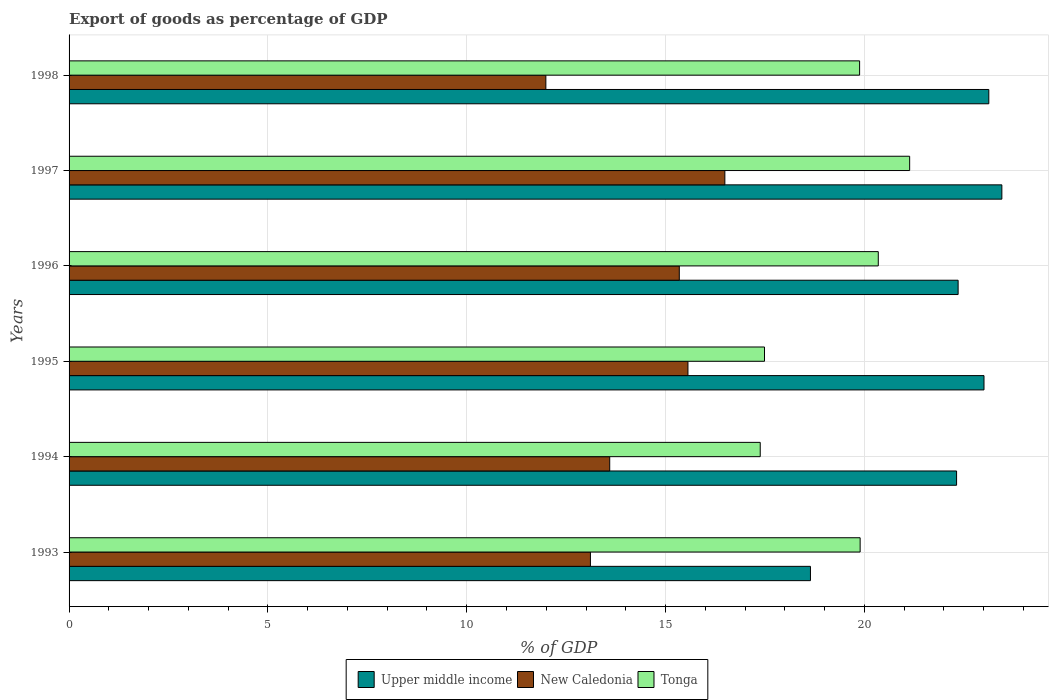How many different coloured bars are there?
Your answer should be compact. 3. How many groups of bars are there?
Your answer should be very brief. 6. Are the number of bars per tick equal to the number of legend labels?
Your response must be concise. Yes. How many bars are there on the 5th tick from the top?
Ensure brevity in your answer.  3. How many bars are there on the 5th tick from the bottom?
Make the answer very short. 3. What is the export of goods as percentage of GDP in New Caledonia in 1995?
Keep it short and to the point. 15.56. Across all years, what is the maximum export of goods as percentage of GDP in Upper middle income?
Your answer should be compact. 23.46. Across all years, what is the minimum export of goods as percentage of GDP in Upper middle income?
Ensure brevity in your answer.  18.64. What is the total export of goods as percentage of GDP in Tonga in the graph?
Offer a terse response. 116.13. What is the difference between the export of goods as percentage of GDP in New Caledonia in 1994 and that in 1997?
Ensure brevity in your answer.  -2.9. What is the difference between the export of goods as percentage of GDP in Tonga in 1993 and the export of goods as percentage of GDP in Upper middle income in 1996?
Offer a terse response. -2.46. What is the average export of goods as percentage of GDP in Tonga per year?
Make the answer very short. 19.36. In the year 1996, what is the difference between the export of goods as percentage of GDP in Tonga and export of goods as percentage of GDP in Upper middle income?
Keep it short and to the point. -2.01. What is the ratio of the export of goods as percentage of GDP in New Caledonia in 1996 to that in 1997?
Your response must be concise. 0.93. Is the export of goods as percentage of GDP in Tonga in 1993 less than that in 1996?
Ensure brevity in your answer.  Yes. What is the difference between the highest and the second highest export of goods as percentage of GDP in Tonga?
Provide a short and direct response. 0.79. What is the difference between the highest and the lowest export of goods as percentage of GDP in New Caledonia?
Your response must be concise. 4.5. In how many years, is the export of goods as percentage of GDP in New Caledonia greater than the average export of goods as percentage of GDP in New Caledonia taken over all years?
Provide a short and direct response. 3. What does the 3rd bar from the top in 1996 represents?
Ensure brevity in your answer.  Upper middle income. What does the 2nd bar from the bottom in 1993 represents?
Your answer should be compact. New Caledonia. How many bars are there?
Provide a short and direct response. 18. Are all the bars in the graph horizontal?
Provide a short and direct response. Yes. How many years are there in the graph?
Provide a succinct answer. 6. Does the graph contain any zero values?
Make the answer very short. No. Where does the legend appear in the graph?
Your response must be concise. Bottom center. How are the legend labels stacked?
Offer a very short reply. Horizontal. What is the title of the graph?
Offer a terse response. Export of goods as percentage of GDP. What is the label or title of the X-axis?
Your answer should be compact. % of GDP. What is the % of GDP of Upper middle income in 1993?
Your answer should be very brief. 18.64. What is the % of GDP of New Caledonia in 1993?
Your answer should be compact. 13.11. What is the % of GDP in Tonga in 1993?
Your answer should be very brief. 19.89. What is the % of GDP in Upper middle income in 1994?
Your answer should be very brief. 22.32. What is the % of GDP of New Caledonia in 1994?
Offer a terse response. 13.6. What is the % of GDP in Tonga in 1994?
Your answer should be compact. 17.38. What is the % of GDP in Upper middle income in 1995?
Make the answer very short. 23.01. What is the % of GDP of New Caledonia in 1995?
Your answer should be compact. 15.56. What is the % of GDP of Tonga in 1995?
Provide a succinct answer. 17.49. What is the % of GDP of Upper middle income in 1996?
Make the answer very short. 22.36. What is the % of GDP in New Caledonia in 1996?
Make the answer very short. 15.35. What is the % of GDP in Tonga in 1996?
Your answer should be very brief. 20.35. What is the % of GDP of Upper middle income in 1997?
Your response must be concise. 23.46. What is the % of GDP of New Caledonia in 1997?
Your answer should be compact. 16.49. What is the % of GDP in Tonga in 1997?
Offer a very short reply. 21.14. What is the % of GDP in Upper middle income in 1998?
Make the answer very short. 23.13. What is the % of GDP of New Caledonia in 1998?
Keep it short and to the point. 11.99. What is the % of GDP of Tonga in 1998?
Make the answer very short. 19.88. Across all years, what is the maximum % of GDP of Upper middle income?
Offer a very short reply. 23.46. Across all years, what is the maximum % of GDP of New Caledonia?
Your answer should be very brief. 16.49. Across all years, what is the maximum % of GDP of Tonga?
Make the answer very short. 21.14. Across all years, what is the minimum % of GDP in Upper middle income?
Ensure brevity in your answer.  18.64. Across all years, what is the minimum % of GDP in New Caledonia?
Your answer should be very brief. 11.99. Across all years, what is the minimum % of GDP in Tonga?
Keep it short and to the point. 17.38. What is the total % of GDP of Upper middle income in the graph?
Offer a very short reply. 132.92. What is the total % of GDP of New Caledonia in the graph?
Keep it short and to the point. 86.1. What is the total % of GDP in Tonga in the graph?
Ensure brevity in your answer.  116.13. What is the difference between the % of GDP in Upper middle income in 1993 and that in 1994?
Your answer should be compact. -3.67. What is the difference between the % of GDP in New Caledonia in 1993 and that in 1994?
Your answer should be compact. -0.48. What is the difference between the % of GDP of Tonga in 1993 and that in 1994?
Make the answer very short. 2.51. What is the difference between the % of GDP in Upper middle income in 1993 and that in 1995?
Provide a succinct answer. -4.36. What is the difference between the % of GDP of New Caledonia in 1993 and that in 1995?
Your answer should be very brief. -2.45. What is the difference between the % of GDP in Tonga in 1993 and that in 1995?
Ensure brevity in your answer.  2.41. What is the difference between the % of GDP in Upper middle income in 1993 and that in 1996?
Your answer should be compact. -3.71. What is the difference between the % of GDP of New Caledonia in 1993 and that in 1996?
Ensure brevity in your answer.  -2.24. What is the difference between the % of GDP of Tonga in 1993 and that in 1996?
Give a very brief answer. -0.46. What is the difference between the % of GDP in Upper middle income in 1993 and that in 1997?
Offer a very short reply. -4.81. What is the difference between the % of GDP in New Caledonia in 1993 and that in 1997?
Your answer should be very brief. -3.38. What is the difference between the % of GDP in Tonga in 1993 and that in 1997?
Your answer should be very brief. -1.25. What is the difference between the % of GDP in Upper middle income in 1993 and that in 1998?
Your response must be concise. -4.49. What is the difference between the % of GDP in New Caledonia in 1993 and that in 1998?
Give a very brief answer. 1.12. What is the difference between the % of GDP of Tonga in 1993 and that in 1998?
Offer a terse response. 0.01. What is the difference between the % of GDP in Upper middle income in 1994 and that in 1995?
Ensure brevity in your answer.  -0.69. What is the difference between the % of GDP in New Caledonia in 1994 and that in 1995?
Provide a succinct answer. -1.97. What is the difference between the % of GDP of Tonga in 1994 and that in 1995?
Your answer should be compact. -0.11. What is the difference between the % of GDP in Upper middle income in 1994 and that in 1996?
Ensure brevity in your answer.  -0.04. What is the difference between the % of GDP in New Caledonia in 1994 and that in 1996?
Make the answer very short. -1.75. What is the difference between the % of GDP in Tonga in 1994 and that in 1996?
Your answer should be compact. -2.97. What is the difference between the % of GDP of Upper middle income in 1994 and that in 1997?
Make the answer very short. -1.14. What is the difference between the % of GDP of New Caledonia in 1994 and that in 1997?
Provide a succinct answer. -2.9. What is the difference between the % of GDP of Tonga in 1994 and that in 1997?
Make the answer very short. -3.76. What is the difference between the % of GDP of Upper middle income in 1994 and that in 1998?
Offer a very short reply. -0.81. What is the difference between the % of GDP of New Caledonia in 1994 and that in 1998?
Give a very brief answer. 1.61. What is the difference between the % of GDP of Tonga in 1994 and that in 1998?
Your response must be concise. -2.5. What is the difference between the % of GDP in Upper middle income in 1995 and that in 1996?
Your response must be concise. 0.65. What is the difference between the % of GDP of New Caledonia in 1995 and that in 1996?
Your response must be concise. 0.22. What is the difference between the % of GDP in Tonga in 1995 and that in 1996?
Offer a terse response. -2.86. What is the difference between the % of GDP in Upper middle income in 1995 and that in 1997?
Offer a terse response. -0.45. What is the difference between the % of GDP of New Caledonia in 1995 and that in 1997?
Make the answer very short. -0.93. What is the difference between the % of GDP in Tonga in 1995 and that in 1997?
Offer a very short reply. -3.65. What is the difference between the % of GDP in Upper middle income in 1995 and that in 1998?
Your response must be concise. -0.12. What is the difference between the % of GDP of New Caledonia in 1995 and that in 1998?
Keep it short and to the point. 3.57. What is the difference between the % of GDP in Tonga in 1995 and that in 1998?
Provide a short and direct response. -2.39. What is the difference between the % of GDP in Upper middle income in 1996 and that in 1997?
Your answer should be compact. -1.1. What is the difference between the % of GDP in New Caledonia in 1996 and that in 1997?
Offer a terse response. -1.15. What is the difference between the % of GDP of Tonga in 1996 and that in 1997?
Your answer should be compact. -0.79. What is the difference between the % of GDP in Upper middle income in 1996 and that in 1998?
Your answer should be very brief. -0.77. What is the difference between the % of GDP of New Caledonia in 1996 and that in 1998?
Your answer should be very brief. 3.36. What is the difference between the % of GDP in Tonga in 1996 and that in 1998?
Give a very brief answer. 0.47. What is the difference between the % of GDP of Upper middle income in 1997 and that in 1998?
Ensure brevity in your answer.  0.33. What is the difference between the % of GDP in New Caledonia in 1997 and that in 1998?
Your answer should be very brief. 4.5. What is the difference between the % of GDP in Tonga in 1997 and that in 1998?
Provide a succinct answer. 1.26. What is the difference between the % of GDP in Upper middle income in 1993 and the % of GDP in New Caledonia in 1994?
Provide a succinct answer. 5.05. What is the difference between the % of GDP of Upper middle income in 1993 and the % of GDP of Tonga in 1994?
Provide a short and direct response. 1.26. What is the difference between the % of GDP in New Caledonia in 1993 and the % of GDP in Tonga in 1994?
Your answer should be compact. -4.27. What is the difference between the % of GDP of Upper middle income in 1993 and the % of GDP of New Caledonia in 1995?
Offer a very short reply. 3.08. What is the difference between the % of GDP in Upper middle income in 1993 and the % of GDP in Tonga in 1995?
Provide a succinct answer. 1.16. What is the difference between the % of GDP in New Caledonia in 1993 and the % of GDP in Tonga in 1995?
Your answer should be very brief. -4.38. What is the difference between the % of GDP of Upper middle income in 1993 and the % of GDP of New Caledonia in 1996?
Ensure brevity in your answer.  3.3. What is the difference between the % of GDP of Upper middle income in 1993 and the % of GDP of Tonga in 1996?
Make the answer very short. -1.71. What is the difference between the % of GDP of New Caledonia in 1993 and the % of GDP of Tonga in 1996?
Provide a short and direct response. -7.24. What is the difference between the % of GDP in Upper middle income in 1993 and the % of GDP in New Caledonia in 1997?
Provide a succinct answer. 2.15. What is the difference between the % of GDP of Upper middle income in 1993 and the % of GDP of Tonga in 1997?
Keep it short and to the point. -2.49. What is the difference between the % of GDP in New Caledonia in 1993 and the % of GDP in Tonga in 1997?
Provide a succinct answer. -8.03. What is the difference between the % of GDP in Upper middle income in 1993 and the % of GDP in New Caledonia in 1998?
Your response must be concise. 6.65. What is the difference between the % of GDP of Upper middle income in 1993 and the % of GDP of Tonga in 1998?
Give a very brief answer. -1.24. What is the difference between the % of GDP of New Caledonia in 1993 and the % of GDP of Tonga in 1998?
Give a very brief answer. -6.77. What is the difference between the % of GDP in Upper middle income in 1994 and the % of GDP in New Caledonia in 1995?
Give a very brief answer. 6.76. What is the difference between the % of GDP in Upper middle income in 1994 and the % of GDP in Tonga in 1995?
Offer a terse response. 4.83. What is the difference between the % of GDP of New Caledonia in 1994 and the % of GDP of Tonga in 1995?
Provide a succinct answer. -3.89. What is the difference between the % of GDP in Upper middle income in 1994 and the % of GDP in New Caledonia in 1996?
Offer a very short reply. 6.97. What is the difference between the % of GDP in Upper middle income in 1994 and the % of GDP in Tonga in 1996?
Your answer should be very brief. 1.97. What is the difference between the % of GDP of New Caledonia in 1994 and the % of GDP of Tonga in 1996?
Provide a succinct answer. -6.75. What is the difference between the % of GDP in Upper middle income in 1994 and the % of GDP in New Caledonia in 1997?
Keep it short and to the point. 5.83. What is the difference between the % of GDP in Upper middle income in 1994 and the % of GDP in Tonga in 1997?
Give a very brief answer. 1.18. What is the difference between the % of GDP in New Caledonia in 1994 and the % of GDP in Tonga in 1997?
Provide a succinct answer. -7.54. What is the difference between the % of GDP of Upper middle income in 1994 and the % of GDP of New Caledonia in 1998?
Your answer should be compact. 10.33. What is the difference between the % of GDP of Upper middle income in 1994 and the % of GDP of Tonga in 1998?
Keep it short and to the point. 2.44. What is the difference between the % of GDP of New Caledonia in 1994 and the % of GDP of Tonga in 1998?
Your answer should be compact. -6.28. What is the difference between the % of GDP in Upper middle income in 1995 and the % of GDP in New Caledonia in 1996?
Your response must be concise. 7.66. What is the difference between the % of GDP of Upper middle income in 1995 and the % of GDP of Tonga in 1996?
Your answer should be very brief. 2.66. What is the difference between the % of GDP in New Caledonia in 1995 and the % of GDP in Tonga in 1996?
Make the answer very short. -4.79. What is the difference between the % of GDP in Upper middle income in 1995 and the % of GDP in New Caledonia in 1997?
Keep it short and to the point. 6.52. What is the difference between the % of GDP in Upper middle income in 1995 and the % of GDP in Tonga in 1997?
Provide a succinct answer. 1.87. What is the difference between the % of GDP in New Caledonia in 1995 and the % of GDP in Tonga in 1997?
Provide a short and direct response. -5.58. What is the difference between the % of GDP of Upper middle income in 1995 and the % of GDP of New Caledonia in 1998?
Give a very brief answer. 11.02. What is the difference between the % of GDP in Upper middle income in 1995 and the % of GDP in Tonga in 1998?
Provide a succinct answer. 3.13. What is the difference between the % of GDP in New Caledonia in 1995 and the % of GDP in Tonga in 1998?
Your answer should be very brief. -4.32. What is the difference between the % of GDP in Upper middle income in 1996 and the % of GDP in New Caledonia in 1997?
Your answer should be very brief. 5.87. What is the difference between the % of GDP in Upper middle income in 1996 and the % of GDP in Tonga in 1997?
Your answer should be very brief. 1.22. What is the difference between the % of GDP of New Caledonia in 1996 and the % of GDP of Tonga in 1997?
Your response must be concise. -5.79. What is the difference between the % of GDP of Upper middle income in 1996 and the % of GDP of New Caledonia in 1998?
Provide a short and direct response. 10.37. What is the difference between the % of GDP in Upper middle income in 1996 and the % of GDP in Tonga in 1998?
Keep it short and to the point. 2.48. What is the difference between the % of GDP of New Caledonia in 1996 and the % of GDP of Tonga in 1998?
Ensure brevity in your answer.  -4.53. What is the difference between the % of GDP in Upper middle income in 1997 and the % of GDP in New Caledonia in 1998?
Offer a very short reply. 11.47. What is the difference between the % of GDP of Upper middle income in 1997 and the % of GDP of Tonga in 1998?
Your answer should be compact. 3.58. What is the difference between the % of GDP in New Caledonia in 1997 and the % of GDP in Tonga in 1998?
Give a very brief answer. -3.39. What is the average % of GDP of Upper middle income per year?
Provide a succinct answer. 22.15. What is the average % of GDP of New Caledonia per year?
Offer a terse response. 14.35. What is the average % of GDP in Tonga per year?
Offer a terse response. 19.36. In the year 1993, what is the difference between the % of GDP of Upper middle income and % of GDP of New Caledonia?
Ensure brevity in your answer.  5.53. In the year 1993, what is the difference between the % of GDP of Upper middle income and % of GDP of Tonga?
Provide a short and direct response. -1.25. In the year 1993, what is the difference between the % of GDP in New Caledonia and % of GDP in Tonga?
Offer a terse response. -6.78. In the year 1994, what is the difference between the % of GDP in Upper middle income and % of GDP in New Caledonia?
Provide a succinct answer. 8.72. In the year 1994, what is the difference between the % of GDP of Upper middle income and % of GDP of Tonga?
Offer a very short reply. 4.94. In the year 1994, what is the difference between the % of GDP of New Caledonia and % of GDP of Tonga?
Your response must be concise. -3.79. In the year 1995, what is the difference between the % of GDP in Upper middle income and % of GDP in New Caledonia?
Your answer should be compact. 7.45. In the year 1995, what is the difference between the % of GDP of Upper middle income and % of GDP of Tonga?
Keep it short and to the point. 5.52. In the year 1995, what is the difference between the % of GDP of New Caledonia and % of GDP of Tonga?
Offer a very short reply. -1.92. In the year 1996, what is the difference between the % of GDP of Upper middle income and % of GDP of New Caledonia?
Your answer should be very brief. 7.01. In the year 1996, what is the difference between the % of GDP in Upper middle income and % of GDP in Tonga?
Provide a succinct answer. 2.01. In the year 1996, what is the difference between the % of GDP in New Caledonia and % of GDP in Tonga?
Your answer should be compact. -5. In the year 1997, what is the difference between the % of GDP in Upper middle income and % of GDP in New Caledonia?
Give a very brief answer. 6.97. In the year 1997, what is the difference between the % of GDP of Upper middle income and % of GDP of Tonga?
Give a very brief answer. 2.32. In the year 1997, what is the difference between the % of GDP in New Caledonia and % of GDP in Tonga?
Give a very brief answer. -4.65. In the year 1998, what is the difference between the % of GDP in Upper middle income and % of GDP in New Caledonia?
Give a very brief answer. 11.14. In the year 1998, what is the difference between the % of GDP in Upper middle income and % of GDP in Tonga?
Offer a very short reply. 3.25. In the year 1998, what is the difference between the % of GDP in New Caledonia and % of GDP in Tonga?
Your answer should be very brief. -7.89. What is the ratio of the % of GDP in Upper middle income in 1993 to that in 1994?
Your answer should be very brief. 0.84. What is the ratio of the % of GDP in New Caledonia in 1993 to that in 1994?
Your response must be concise. 0.96. What is the ratio of the % of GDP of Tonga in 1993 to that in 1994?
Your answer should be very brief. 1.14. What is the ratio of the % of GDP of Upper middle income in 1993 to that in 1995?
Your answer should be very brief. 0.81. What is the ratio of the % of GDP in New Caledonia in 1993 to that in 1995?
Provide a short and direct response. 0.84. What is the ratio of the % of GDP in Tonga in 1993 to that in 1995?
Ensure brevity in your answer.  1.14. What is the ratio of the % of GDP in Upper middle income in 1993 to that in 1996?
Provide a short and direct response. 0.83. What is the ratio of the % of GDP of New Caledonia in 1993 to that in 1996?
Ensure brevity in your answer.  0.85. What is the ratio of the % of GDP in Tonga in 1993 to that in 1996?
Provide a succinct answer. 0.98. What is the ratio of the % of GDP of Upper middle income in 1993 to that in 1997?
Your answer should be compact. 0.79. What is the ratio of the % of GDP of New Caledonia in 1993 to that in 1997?
Make the answer very short. 0.8. What is the ratio of the % of GDP in Tonga in 1993 to that in 1997?
Provide a short and direct response. 0.94. What is the ratio of the % of GDP in Upper middle income in 1993 to that in 1998?
Provide a short and direct response. 0.81. What is the ratio of the % of GDP in New Caledonia in 1993 to that in 1998?
Your answer should be very brief. 1.09. What is the ratio of the % of GDP of Upper middle income in 1994 to that in 1995?
Your response must be concise. 0.97. What is the ratio of the % of GDP in New Caledonia in 1994 to that in 1995?
Your answer should be compact. 0.87. What is the ratio of the % of GDP in Upper middle income in 1994 to that in 1996?
Provide a short and direct response. 1. What is the ratio of the % of GDP in New Caledonia in 1994 to that in 1996?
Ensure brevity in your answer.  0.89. What is the ratio of the % of GDP in Tonga in 1994 to that in 1996?
Keep it short and to the point. 0.85. What is the ratio of the % of GDP of Upper middle income in 1994 to that in 1997?
Your answer should be compact. 0.95. What is the ratio of the % of GDP of New Caledonia in 1994 to that in 1997?
Your answer should be compact. 0.82. What is the ratio of the % of GDP of Tonga in 1994 to that in 1997?
Keep it short and to the point. 0.82. What is the ratio of the % of GDP in Upper middle income in 1994 to that in 1998?
Your answer should be compact. 0.96. What is the ratio of the % of GDP of New Caledonia in 1994 to that in 1998?
Your response must be concise. 1.13. What is the ratio of the % of GDP of Tonga in 1994 to that in 1998?
Make the answer very short. 0.87. What is the ratio of the % of GDP of Upper middle income in 1995 to that in 1996?
Your answer should be compact. 1.03. What is the ratio of the % of GDP in New Caledonia in 1995 to that in 1996?
Give a very brief answer. 1.01. What is the ratio of the % of GDP in Tonga in 1995 to that in 1996?
Give a very brief answer. 0.86. What is the ratio of the % of GDP of Upper middle income in 1995 to that in 1997?
Keep it short and to the point. 0.98. What is the ratio of the % of GDP in New Caledonia in 1995 to that in 1997?
Your answer should be compact. 0.94. What is the ratio of the % of GDP in Tonga in 1995 to that in 1997?
Your answer should be compact. 0.83. What is the ratio of the % of GDP of New Caledonia in 1995 to that in 1998?
Your answer should be compact. 1.3. What is the ratio of the % of GDP in Tonga in 1995 to that in 1998?
Your answer should be very brief. 0.88. What is the ratio of the % of GDP of Upper middle income in 1996 to that in 1997?
Provide a short and direct response. 0.95. What is the ratio of the % of GDP in New Caledonia in 1996 to that in 1997?
Offer a terse response. 0.93. What is the ratio of the % of GDP of Tonga in 1996 to that in 1997?
Your answer should be compact. 0.96. What is the ratio of the % of GDP in Upper middle income in 1996 to that in 1998?
Ensure brevity in your answer.  0.97. What is the ratio of the % of GDP in New Caledonia in 1996 to that in 1998?
Offer a terse response. 1.28. What is the ratio of the % of GDP of Tonga in 1996 to that in 1998?
Provide a short and direct response. 1.02. What is the ratio of the % of GDP in Upper middle income in 1997 to that in 1998?
Offer a terse response. 1.01. What is the ratio of the % of GDP of New Caledonia in 1997 to that in 1998?
Your response must be concise. 1.38. What is the ratio of the % of GDP in Tonga in 1997 to that in 1998?
Give a very brief answer. 1.06. What is the difference between the highest and the second highest % of GDP in Upper middle income?
Offer a terse response. 0.33. What is the difference between the highest and the second highest % of GDP of New Caledonia?
Make the answer very short. 0.93. What is the difference between the highest and the second highest % of GDP of Tonga?
Provide a succinct answer. 0.79. What is the difference between the highest and the lowest % of GDP of Upper middle income?
Your answer should be very brief. 4.81. What is the difference between the highest and the lowest % of GDP of New Caledonia?
Make the answer very short. 4.5. What is the difference between the highest and the lowest % of GDP of Tonga?
Make the answer very short. 3.76. 